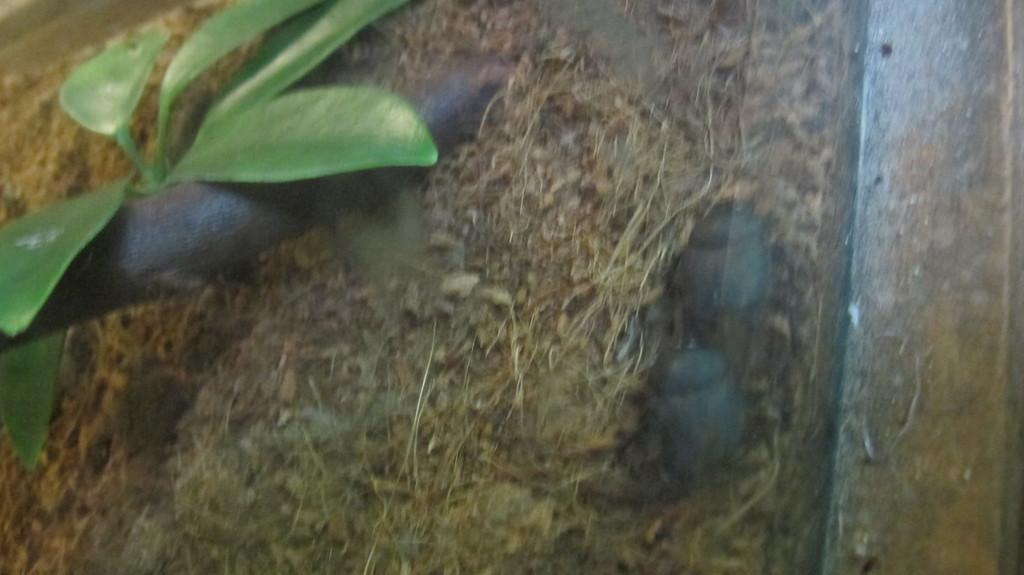What type of living organism is present in the image? There is a small plant in the image. What type of ship can be seen sailing in the background of the image? There is no ship present in the image; it only features a small plant. What type of thunder can be heard in the image? There is no sound, including thunder, present in the image, as it is a still image. 